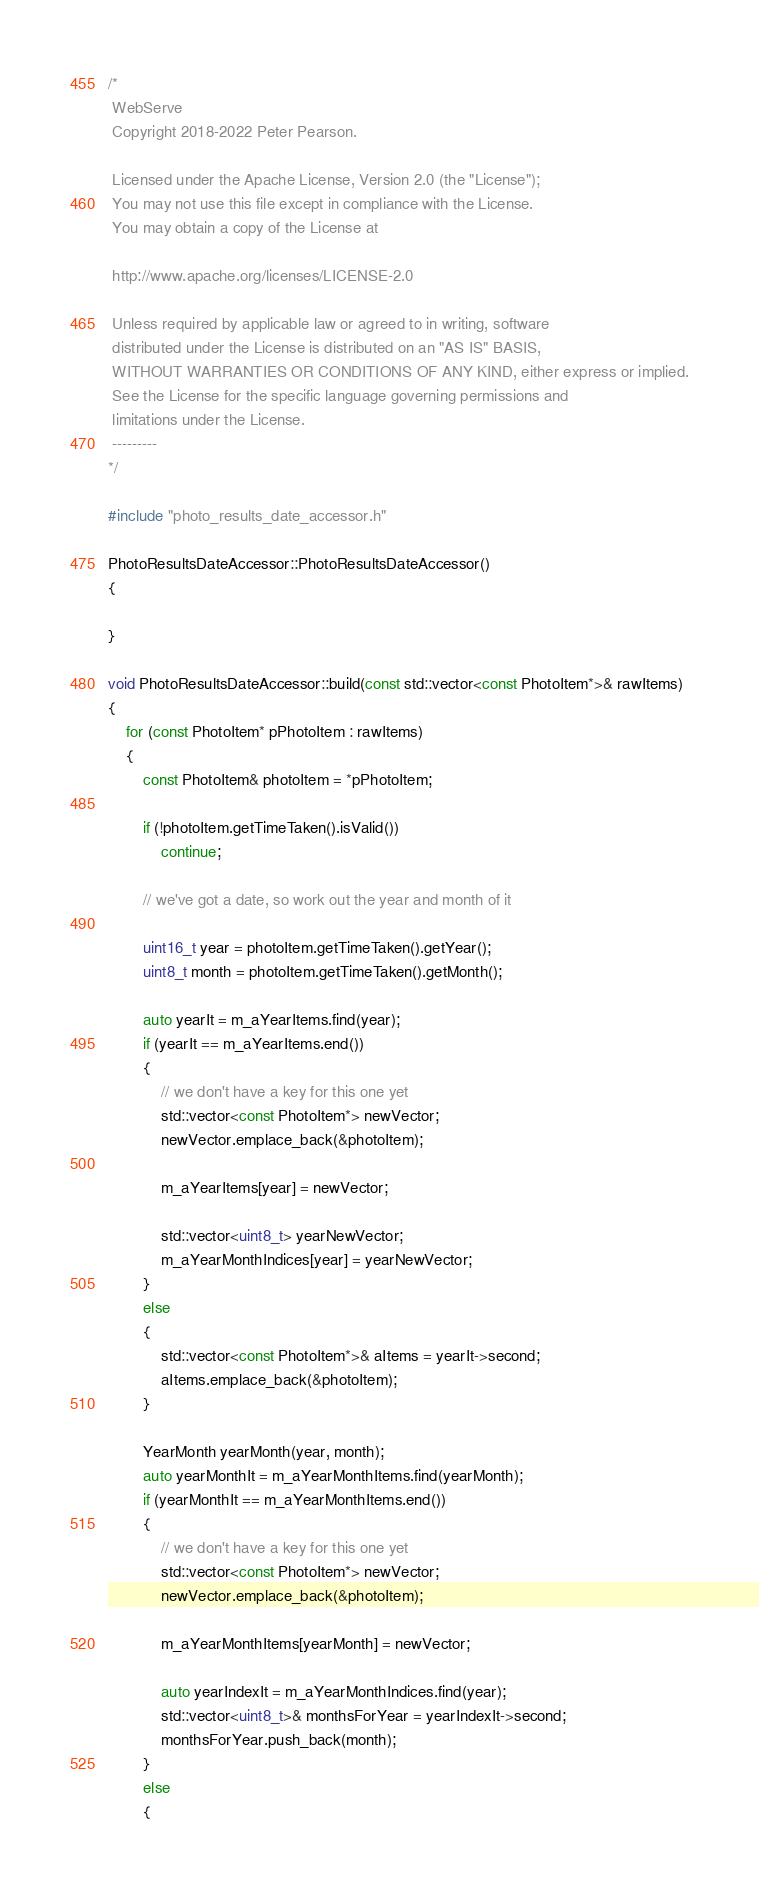<code> <loc_0><loc_0><loc_500><loc_500><_C++_>/*
 WebServe
 Copyright 2018-2022 Peter Pearson.

 Licensed under the Apache License, Version 2.0 (the "License");
 You may not use this file except in compliance with the License.
 You may obtain a copy of the License at

 http://www.apache.org/licenses/LICENSE-2.0

 Unless required by applicable law or agreed to in writing, software
 distributed under the License is distributed on an "AS IS" BASIS,
 WITHOUT WARRANTIES OR CONDITIONS OF ANY KIND, either express or implied.
 See the License for the specific language governing permissions and
 limitations under the License.
 ---------
*/

#include "photo_results_date_accessor.h"

PhotoResultsDateAccessor::PhotoResultsDateAccessor()
{

}

void PhotoResultsDateAccessor::build(const std::vector<const PhotoItem*>& rawItems)
{
	for (const PhotoItem* pPhotoItem : rawItems)
	{
		const PhotoItem& photoItem = *pPhotoItem;

		if (!photoItem.getTimeTaken().isValid())
			continue;

		// we've got a date, so work out the year and month of it

		uint16_t year = photoItem.getTimeTaken().getYear();
		uint8_t month = photoItem.getTimeTaken().getMonth();

		auto yearIt = m_aYearItems.find(year);
		if (yearIt == m_aYearItems.end())
		{
			// we don't have a key for this one yet
			std::vector<const PhotoItem*> newVector;
			newVector.emplace_back(&photoItem);

			m_aYearItems[year] = newVector;

			std::vector<uint8_t> yearNewVector;
			m_aYearMonthIndices[year] = yearNewVector;
		}
		else
		{
			std::vector<const PhotoItem*>& aItems = yearIt->second;
			aItems.emplace_back(&photoItem);
		}

		YearMonth yearMonth(year, month);
		auto yearMonthIt = m_aYearMonthItems.find(yearMonth);
		if (yearMonthIt == m_aYearMonthItems.end())
		{
			// we don't have a key for this one yet
			std::vector<const PhotoItem*> newVector;
			newVector.emplace_back(&photoItem);

			m_aYearMonthItems[yearMonth] = newVector;

			auto yearIndexIt = m_aYearMonthIndices.find(year);
			std::vector<uint8_t>& monthsForYear = yearIndexIt->second;
			monthsForYear.push_back(month);
		}
		else
		{</code> 